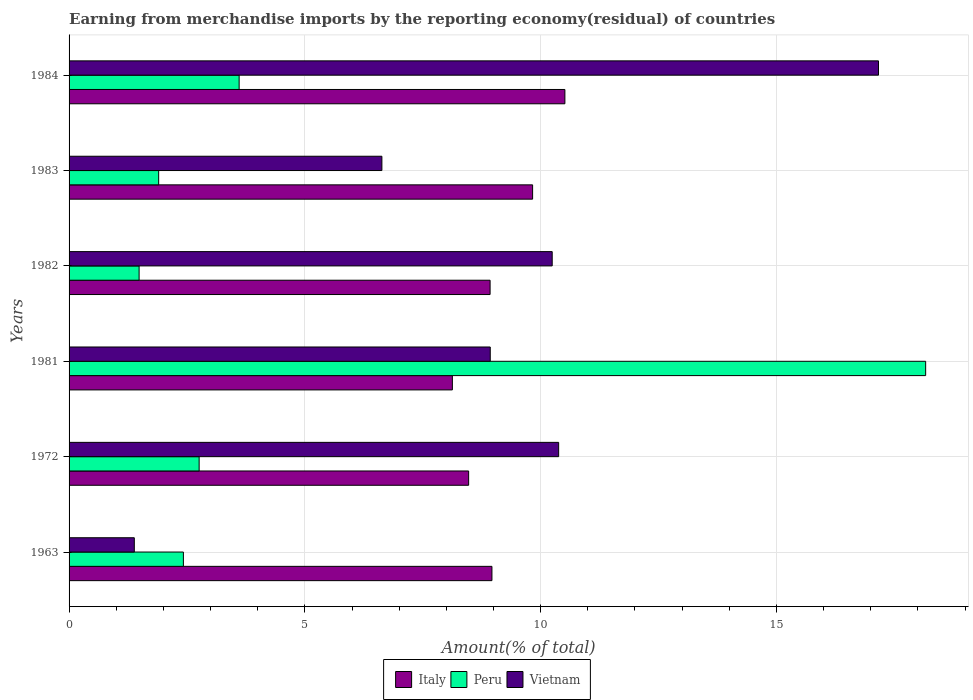How many different coloured bars are there?
Your response must be concise. 3. How many groups of bars are there?
Your answer should be compact. 6. How many bars are there on the 5th tick from the top?
Ensure brevity in your answer.  3. How many bars are there on the 1st tick from the bottom?
Provide a succinct answer. 3. In how many cases, is the number of bars for a given year not equal to the number of legend labels?
Offer a very short reply. 0. What is the percentage of amount earned from merchandise imports in Peru in 1972?
Your answer should be compact. 2.76. Across all years, what is the maximum percentage of amount earned from merchandise imports in Italy?
Ensure brevity in your answer.  10.51. Across all years, what is the minimum percentage of amount earned from merchandise imports in Italy?
Your response must be concise. 8.13. What is the total percentage of amount earned from merchandise imports in Italy in the graph?
Provide a succinct answer. 54.84. What is the difference between the percentage of amount earned from merchandise imports in Italy in 1982 and that in 1983?
Ensure brevity in your answer.  -0.9. What is the difference between the percentage of amount earned from merchandise imports in Peru in 1983 and the percentage of amount earned from merchandise imports in Vietnam in 1963?
Offer a terse response. 0.52. What is the average percentage of amount earned from merchandise imports in Vietnam per year?
Make the answer very short. 9.12. In the year 1984, what is the difference between the percentage of amount earned from merchandise imports in Italy and percentage of amount earned from merchandise imports in Peru?
Provide a succinct answer. 6.91. What is the ratio of the percentage of amount earned from merchandise imports in Peru in 1981 to that in 1983?
Offer a very short reply. 9.56. Is the percentage of amount earned from merchandise imports in Italy in 1981 less than that in 1983?
Give a very brief answer. Yes. What is the difference between the highest and the second highest percentage of amount earned from merchandise imports in Vietnam?
Make the answer very short. 6.78. What is the difference between the highest and the lowest percentage of amount earned from merchandise imports in Peru?
Offer a very short reply. 16.68. In how many years, is the percentage of amount earned from merchandise imports in Italy greater than the average percentage of amount earned from merchandise imports in Italy taken over all years?
Your answer should be very brief. 2. What does the 1st bar from the top in 1983 represents?
Provide a succinct answer. Vietnam. What does the 2nd bar from the bottom in 1981 represents?
Ensure brevity in your answer.  Peru. Is it the case that in every year, the sum of the percentage of amount earned from merchandise imports in Peru and percentage of amount earned from merchandise imports in Vietnam is greater than the percentage of amount earned from merchandise imports in Italy?
Keep it short and to the point. No. Are all the bars in the graph horizontal?
Your answer should be very brief. Yes. How many years are there in the graph?
Provide a succinct answer. 6. What is the difference between two consecutive major ticks on the X-axis?
Your answer should be very brief. 5. Does the graph contain any zero values?
Provide a succinct answer. No. What is the title of the graph?
Provide a succinct answer. Earning from merchandise imports by the reporting economy(residual) of countries. What is the label or title of the X-axis?
Provide a short and direct response. Amount(% of total). What is the Amount(% of total) in Italy in 1963?
Make the answer very short. 8.97. What is the Amount(% of total) of Peru in 1963?
Make the answer very short. 2.42. What is the Amount(% of total) in Vietnam in 1963?
Your response must be concise. 1.38. What is the Amount(% of total) in Italy in 1972?
Keep it short and to the point. 8.47. What is the Amount(% of total) in Peru in 1972?
Make the answer very short. 2.76. What is the Amount(% of total) of Vietnam in 1972?
Make the answer very short. 10.38. What is the Amount(% of total) in Italy in 1981?
Your answer should be very brief. 8.13. What is the Amount(% of total) of Peru in 1981?
Provide a succinct answer. 18.16. What is the Amount(% of total) of Vietnam in 1981?
Provide a short and direct response. 8.93. What is the Amount(% of total) in Italy in 1982?
Your response must be concise. 8.93. What is the Amount(% of total) in Peru in 1982?
Make the answer very short. 1.49. What is the Amount(% of total) in Vietnam in 1982?
Give a very brief answer. 10.24. What is the Amount(% of total) of Italy in 1983?
Provide a short and direct response. 9.83. What is the Amount(% of total) of Peru in 1983?
Give a very brief answer. 1.9. What is the Amount(% of total) in Vietnam in 1983?
Keep it short and to the point. 6.63. What is the Amount(% of total) of Italy in 1984?
Your answer should be very brief. 10.51. What is the Amount(% of total) of Peru in 1984?
Give a very brief answer. 3.61. What is the Amount(% of total) in Vietnam in 1984?
Provide a short and direct response. 17.16. Across all years, what is the maximum Amount(% of total) in Italy?
Ensure brevity in your answer.  10.51. Across all years, what is the maximum Amount(% of total) of Peru?
Ensure brevity in your answer.  18.16. Across all years, what is the maximum Amount(% of total) in Vietnam?
Ensure brevity in your answer.  17.16. Across all years, what is the minimum Amount(% of total) of Italy?
Ensure brevity in your answer.  8.13. Across all years, what is the minimum Amount(% of total) of Peru?
Offer a very short reply. 1.49. Across all years, what is the minimum Amount(% of total) of Vietnam?
Provide a short and direct response. 1.38. What is the total Amount(% of total) in Italy in the graph?
Make the answer very short. 54.84. What is the total Amount(% of total) of Peru in the graph?
Make the answer very short. 30.34. What is the total Amount(% of total) in Vietnam in the graph?
Keep it short and to the point. 54.74. What is the difference between the Amount(% of total) of Italy in 1963 and that in 1972?
Your answer should be compact. 0.49. What is the difference between the Amount(% of total) of Peru in 1963 and that in 1972?
Provide a short and direct response. -0.33. What is the difference between the Amount(% of total) of Vietnam in 1963 and that in 1972?
Offer a very short reply. -9. What is the difference between the Amount(% of total) of Italy in 1963 and that in 1981?
Your response must be concise. 0.84. What is the difference between the Amount(% of total) of Peru in 1963 and that in 1981?
Your answer should be very brief. -15.74. What is the difference between the Amount(% of total) of Vietnam in 1963 and that in 1981?
Your answer should be very brief. -7.55. What is the difference between the Amount(% of total) of Italy in 1963 and that in 1982?
Give a very brief answer. 0.04. What is the difference between the Amount(% of total) of Peru in 1963 and that in 1982?
Your answer should be very brief. 0.94. What is the difference between the Amount(% of total) of Vietnam in 1963 and that in 1982?
Keep it short and to the point. -8.86. What is the difference between the Amount(% of total) of Italy in 1963 and that in 1983?
Your response must be concise. -0.86. What is the difference between the Amount(% of total) in Peru in 1963 and that in 1983?
Provide a succinct answer. 0.52. What is the difference between the Amount(% of total) of Vietnam in 1963 and that in 1983?
Offer a very short reply. -5.25. What is the difference between the Amount(% of total) of Italy in 1963 and that in 1984?
Your answer should be very brief. -1.55. What is the difference between the Amount(% of total) of Peru in 1963 and that in 1984?
Keep it short and to the point. -1.18. What is the difference between the Amount(% of total) of Vietnam in 1963 and that in 1984?
Provide a short and direct response. -15.78. What is the difference between the Amount(% of total) in Italy in 1972 and that in 1981?
Your response must be concise. 0.34. What is the difference between the Amount(% of total) of Peru in 1972 and that in 1981?
Give a very brief answer. -15.41. What is the difference between the Amount(% of total) of Vietnam in 1972 and that in 1981?
Your response must be concise. 1.45. What is the difference between the Amount(% of total) of Italy in 1972 and that in 1982?
Give a very brief answer. -0.46. What is the difference between the Amount(% of total) in Peru in 1972 and that in 1982?
Ensure brevity in your answer.  1.27. What is the difference between the Amount(% of total) in Vietnam in 1972 and that in 1982?
Your answer should be very brief. 0.14. What is the difference between the Amount(% of total) in Italy in 1972 and that in 1983?
Your answer should be compact. -1.36. What is the difference between the Amount(% of total) of Peru in 1972 and that in 1983?
Make the answer very short. 0.86. What is the difference between the Amount(% of total) in Vietnam in 1972 and that in 1983?
Provide a succinct answer. 3.75. What is the difference between the Amount(% of total) in Italy in 1972 and that in 1984?
Make the answer very short. -2.04. What is the difference between the Amount(% of total) of Peru in 1972 and that in 1984?
Provide a short and direct response. -0.85. What is the difference between the Amount(% of total) of Vietnam in 1972 and that in 1984?
Keep it short and to the point. -6.78. What is the difference between the Amount(% of total) in Italy in 1981 and that in 1982?
Make the answer very short. -0.8. What is the difference between the Amount(% of total) in Peru in 1981 and that in 1982?
Make the answer very short. 16.68. What is the difference between the Amount(% of total) in Vietnam in 1981 and that in 1982?
Keep it short and to the point. -1.31. What is the difference between the Amount(% of total) of Italy in 1981 and that in 1983?
Ensure brevity in your answer.  -1.7. What is the difference between the Amount(% of total) in Peru in 1981 and that in 1983?
Keep it short and to the point. 16.26. What is the difference between the Amount(% of total) in Vietnam in 1981 and that in 1983?
Your answer should be compact. 2.3. What is the difference between the Amount(% of total) of Italy in 1981 and that in 1984?
Provide a short and direct response. -2.39. What is the difference between the Amount(% of total) of Peru in 1981 and that in 1984?
Keep it short and to the point. 14.56. What is the difference between the Amount(% of total) in Vietnam in 1981 and that in 1984?
Your answer should be compact. -8.23. What is the difference between the Amount(% of total) in Italy in 1982 and that in 1983?
Keep it short and to the point. -0.9. What is the difference between the Amount(% of total) in Peru in 1982 and that in 1983?
Offer a very short reply. -0.41. What is the difference between the Amount(% of total) in Vietnam in 1982 and that in 1983?
Provide a short and direct response. 3.61. What is the difference between the Amount(% of total) of Italy in 1982 and that in 1984?
Provide a succinct answer. -1.59. What is the difference between the Amount(% of total) of Peru in 1982 and that in 1984?
Make the answer very short. -2.12. What is the difference between the Amount(% of total) in Vietnam in 1982 and that in 1984?
Make the answer very short. -6.92. What is the difference between the Amount(% of total) in Italy in 1983 and that in 1984?
Your response must be concise. -0.68. What is the difference between the Amount(% of total) of Peru in 1983 and that in 1984?
Offer a terse response. -1.71. What is the difference between the Amount(% of total) of Vietnam in 1983 and that in 1984?
Provide a short and direct response. -10.53. What is the difference between the Amount(% of total) in Italy in 1963 and the Amount(% of total) in Peru in 1972?
Provide a succinct answer. 6.21. What is the difference between the Amount(% of total) of Italy in 1963 and the Amount(% of total) of Vietnam in 1972?
Provide a short and direct response. -1.41. What is the difference between the Amount(% of total) of Peru in 1963 and the Amount(% of total) of Vietnam in 1972?
Your answer should be compact. -7.96. What is the difference between the Amount(% of total) of Italy in 1963 and the Amount(% of total) of Peru in 1981?
Make the answer very short. -9.2. What is the difference between the Amount(% of total) in Italy in 1963 and the Amount(% of total) in Vietnam in 1981?
Give a very brief answer. 0.04. What is the difference between the Amount(% of total) of Peru in 1963 and the Amount(% of total) of Vietnam in 1981?
Keep it short and to the point. -6.51. What is the difference between the Amount(% of total) in Italy in 1963 and the Amount(% of total) in Peru in 1982?
Provide a succinct answer. 7.48. What is the difference between the Amount(% of total) of Italy in 1963 and the Amount(% of total) of Vietnam in 1982?
Offer a terse response. -1.28. What is the difference between the Amount(% of total) of Peru in 1963 and the Amount(% of total) of Vietnam in 1982?
Provide a succinct answer. -7.82. What is the difference between the Amount(% of total) of Italy in 1963 and the Amount(% of total) of Peru in 1983?
Your answer should be compact. 7.07. What is the difference between the Amount(% of total) of Italy in 1963 and the Amount(% of total) of Vietnam in 1983?
Offer a very short reply. 2.33. What is the difference between the Amount(% of total) in Peru in 1963 and the Amount(% of total) in Vietnam in 1983?
Your response must be concise. -4.21. What is the difference between the Amount(% of total) in Italy in 1963 and the Amount(% of total) in Peru in 1984?
Make the answer very short. 5.36. What is the difference between the Amount(% of total) in Italy in 1963 and the Amount(% of total) in Vietnam in 1984?
Give a very brief answer. -8.2. What is the difference between the Amount(% of total) of Peru in 1963 and the Amount(% of total) of Vietnam in 1984?
Ensure brevity in your answer.  -14.74. What is the difference between the Amount(% of total) of Italy in 1972 and the Amount(% of total) of Peru in 1981?
Give a very brief answer. -9.69. What is the difference between the Amount(% of total) in Italy in 1972 and the Amount(% of total) in Vietnam in 1981?
Give a very brief answer. -0.46. What is the difference between the Amount(% of total) of Peru in 1972 and the Amount(% of total) of Vietnam in 1981?
Give a very brief answer. -6.17. What is the difference between the Amount(% of total) in Italy in 1972 and the Amount(% of total) in Peru in 1982?
Provide a succinct answer. 6.99. What is the difference between the Amount(% of total) of Italy in 1972 and the Amount(% of total) of Vietnam in 1982?
Make the answer very short. -1.77. What is the difference between the Amount(% of total) of Peru in 1972 and the Amount(% of total) of Vietnam in 1982?
Your answer should be compact. -7.49. What is the difference between the Amount(% of total) in Italy in 1972 and the Amount(% of total) in Peru in 1983?
Offer a very short reply. 6.57. What is the difference between the Amount(% of total) in Italy in 1972 and the Amount(% of total) in Vietnam in 1983?
Provide a succinct answer. 1.84. What is the difference between the Amount(% of total) in Peru in 1972 and the Amount(% of total) in Vietnam in 1983?
Keep it short and to the point. -3.87. What is the difference between the Amount(% of total) in Italy in 1972 and the Amount(% of total) in Peru in 1984?
Keep it short and to the point. 4.87. What is the difference between the Amount(% of total) in Italy in 1972 and the Amount(% of total) in Vietnam in 1984?
Your answer should be compact. -8.69. What is the difference between the Amount(% of total) in Peru in 1972 and the Amount(% of total) in Vietnam in 1984?
Give a very brief answer. -14.41. What is the difference between the Amount(% of total) in Italy in 1981 and the Amount(% of total) in Peru in 1982?
Your answer should be compact. 6.64. What is the difference between the Amount(% of total) in Italy in 1981 and the Amount(% of total) in Vietnam in 1982?
Offer a very short reply. -2.12. What is the difference between the Amount(% of total) of Peru in 1981 and the Amount(% of total) of Vietnam in 1982?
Your answer should be very brief. 7.92. What is the difference between the Amount(% of total) in Italy in 1981 and the Amount(% of total) in Peru in 1983?
Your response must be concise. 6.23. What is the difference between the Amount(% of total) in Italy in 1981 and the Amount(% of total) in Vietnam in 1983?
Your response must be concise. 1.49. What is the difference between the Amount(% of total) in Peru in 1981 and the Amount(% of total) in Vietnam in 1983?
Give a very brief answer. 11.53. What is the difference between the Amount(% of total) in Italy in 1981 and the Amount(% of total) in Peru in 1984?
Offer a terse response. 4.52. What is the difference between the Amount(% of total) of Italy in 1981 and the Amount(% of total) of Vietnam in 1984?
Offer a terse response. -9.04. What is the difference between the Amount(% of total) in Peru in 1981 and the Amount(% of total) in Vietnam in 1984?
Keep it short and to the point. 1. What is the difference between the Amount(% of total) of Italy in 1982 and the Amount(% of total) of Peru in 1983?
Keep it short and to the point. 7.03. What is the difference between the Amount(% of total) of Italy in 1982 and the Amount(% of total) of Vietnam in 1983?
Keep it short and to the point. 2.29. What is the difference between the Amount(% of total) in Peru in 1982 and the Amount(% of total) in Vietnam in 1983?
Ensure brevity in your answer.  -5.15. What is the difference between the Amount(% of total) in Italy in 1982 and the Amount(% of total) in Peru in 1984?
Provide a succinct answer. 5.32. What is the difference between the Amount(% of total) of Italy in 1982 and the Amount(% of total) of Vietnam in 1984?
Provide a succinct answer. -8.24. What is the difference between the Amount(% of total) of Peru in 1982 and the Amount(% of total) of Vietnam in 1984?
Provide a short and direct response. -15.68. What is the difference between the Amount(% of total) of Italy in 1983 and the Amount(% of total) of Peru in 1984?
Provide a short and direct response. 6.22. What is the difference between the Amount(% of total) in Italy in 1983 and the Amount(% of total) in Vietnam in 1984?
Keep it short and to the point. -7.33. What is the difference between the Amount(% of total) of Peru in 1983 and the Amount(% of total) of Vietnam in 1984?
Offer a very short reply. -15.26. What is the average Amount(% of total) in Italy per year?
Your answer should be very brief. 9.14. What is the average Amount(% of total) of Peru per year?
Offer a terse response. 5.06. What is the average Amount(% of total) of Vietnam per year?
Provide a succinct answer. 9.12. In the year 1963, what is the difference between the Amount(% of total) of Italy and Amount(% of total) of Peru?
Your answer should be compact. 6.54. In the year 1963, what is the difference between the Amount(% of total) in Italy and Amount(% of total) in Vietnam?
Provide a short and direct response. 7.58. In the year 1963, what is the difference between the Amount(% of total) of Peru and Amount(% of total) of Vietnam?
Keep it short and to the point. 1.04. In the year 1972, what is the difference between the Amount(% of total) in Italy and Amount(% of total) in Peru?
Provide a succinct answer. 5.71. In the year 1972, what is the difference between the Amount(% of total) in Italy and Amount(% of total) in Vietnam?
Ensure brevity in your answer.  -1.91. In the year 1972, what is the difference between the Amount(% of total) of Peru and Amount(% of total) of Vietnam?
Your answer should be very brief. -7.62. In the year 1981, what is the difference between the Amount(% of total) of Italy and Amount(% of total) of Peru?
Your answer should be very brief. -10.04. In the year 1981, what is the difference between the Amount(% of total) in Italy and Amount(% of total) in Vietnam?
Provide a succinct answer. -0.8. In the year 1981, what is the difference between the Amount(% of total) of Peru and Amount(% of total) of Vietnam?
Offer a very short reply. 9.23. In the year 1982, what is the difference between the Amount(% of total) of Italy and Amount(% of total) of Peru?
Offer a terse response. 7.44. In the year 1982, what is the difference between the Amount(% of total) of Italy and Amount(% of total) of Vietnam?
Keep it short and to the point. -1.32. In the year 1982, what is the difference between the Amount(% of total) in Peru and Amount(% of total) in Vietnam?
Ensure brevity in your answer.  -8.76. In the year 1983, what is the difference between the Amount(% of total) in Italy and Amount(% of total) in Peru?
Make the answer very short. 7.93. In the year 1983, what is the difference between the Amount(% of total) in Italy and Amount(% of total) in Vietnam?
Provide a short and direct response. 3.2. In the year 1983, what is the difference between the Amount(% of total) of Peru and Amount(% of total) of Vietnam?
Offer a terse response. -4.73. In the year 1984, what is the difference between the Amount(% of total) of Italy and Amount(% of total) of Peru?
Your response must be concise. 6.91. In the year 1984, what is the difference between the Amount(% of total) of Italy and Amount(% of total) of Vietnam?
Offer a terse response. -6.65. In the year 1984, what is the difference between the Amount(% of total) of Peru and Amount(% of total) of Vietnam?
Give a very brief answer. -13.56. What is the ratio of the Amount(% of total) in Italy in 1963 to that in 1972?
Your answer should be very brief. 1.06. What is the ratio of the Amount(% of total) of Peru in 1963 to that in 1972?
Your answer should be very brief. 0.88. What is the ratio of the Amount(% of total) in Vietnam in 1963 to that in 1972?
Keep it short and to the point. 0.13. What is the ratio of the Amount(% of total) in Italy in 1963 to that in 1981?
Your answer should be compact. 1.1. What is the ratio of the Amount(% of total) of Peru in 1963 to that in 1981?
Give a very brief answer. 0.13. What is the ratio of the Amount(% of total) of Vietnam in 1963 to that in 1981?
Offer a very short reply. 0.15. What is the ratio of the Amount(% of total) in Peru in 1963 to that in 1982?
Provide a short and direct response. 1.63. What is the ratio of the Amount(% of total) of Vietnam in 1963 to that in 1982?
Your answer should be compact. 0.14. What is the ratio of the Amount(% of total) in Italy in 1963 to that in 1983?
Your answer should be compact. 0.91. What is the ratio of the Amount(% of total) in Peru in 1963 to that in 1983?
Make the answer very short. 1.28. What is the ratio of the Amount(% of total) of Vietnam in 1963 to that in 1983?
Your answer should be compact. 0.21. What is the ratio of the Amount(% of total) in Italy in 1963 to that in 1984?
Ensure brevity in your answer.  0.85. What is the ratio of the Amount(% of total) in Peru in 1963 to that in 1984?
Make the answer very short. 0.67. What is the ratio of the Amount(% of total) of Vietnam in 1963 to that in 1984?
Make the answer very short. 0.08. What is the ratio of the Amount(% of total) in Italy in 1972 to that in 1981?
Offer a very short reply. 1.04. What is the ratio of the Amount(% of total) in Peru in 1972 to that in 1981?
Your answer should be compact. 0.15. What is the ratio of the Amount(% of total) of Vietnam in 1972 to that in 1981?
Ensure brevity in your answer.  1.16. What is the ratio of the Amount(% of total) in Italy in 1972 to that in 1982?
Give a very brief answer. 0.95. What is the ratio of the Amount(% of total) of Peru in 1972 to that in 1982?
Your answer should be compact. 1.86. What is the ratio of the Amount(% of total) in Vietnam in 1972 to that in 1982?
Give a very brief answer. 1.01. What is the ratio of the Amount(% of total) in Italy in 1972 to that in 1983?
Ensure brevity in your answer.  0.86. What is the ratio of the Amount(% of total) in Peru in 1972 to that in 1983?
Give a very brief answer. 1.45. What is the ratio of the Amount(% of total) of Vietnam in 1972 to that in 1983?
Keep it short and to the point. 1.57. What is the ratio of the Amount(% of total) in Italy in 1972 to that in 1984?
Give a very brief answer. 0.81. What is the ratio of the Amount(% of total) of Peru in 1972 to that in 1984?
Your answer should be very brief. 0.76. What is the ratio of the Amount(% of total) of Vietnam in 1972 to that in 1984?
Make the answer very short. 0.6. What is the ratio of the Amount(% of total) in Italy in 1981 to that in 1982?
Offer a terse response. 0.91. What is the ratio of the Amount(% of total) of Peru in 1981 to that in 1982?
Ensure brevity in your answer.  12.23. What is the ratio of the Amount(% of total) of Vietnam in 1981 to that in 1982?
Offer a terse response. 0.87. What is the ratio of the Amount(% of total) in Italy in 1981 to that in 1983?
Make the answer very short. 0.83. What is the ratio of the Amount(% of total) in Peru in 1981 to that in 1983?
Give a very brief answer. 9.56. What is the ratio of the Amount(% of total) of Vietnam in 1981 to that in 1983?
Keep it short and to the point. 1.35. What is the ratio of the Amount(% of total) of Italy in 1981 to that in 1984?
Give a very brief answer. 0.77. What is the ratio of the Amount(% of total) in Peru in 1981 to that in 1984?
Offer a very short reply. 5.04. What is the ratio of the Amount(% of total) in Vietnam in 1981 to that in 1984?
Your response must be concise. 0.52. What is the ratio of the Amount(% of total) in Italy in 1982 to that in 1983?
Keep it short and to the point. 0.91. What is the ratio of the Amount(% of total) of Peru in 1982 to that in 1983?
Make the answer very short. 0.78. What is the ratio of the Amount(% of total) of Vietnam in 1982 to that in 1983?
Keep it short and to the point. 1.54. What is the ratio of the Amount(% of total) in Italy in 1982 to that in 1984?
Ensure brevity in your answer.  0.85. What is the ratio of the Amount(% of total) of Peru in 1982 to that in 1984?
Offer a very short reply. 0.41. What is the ratio of the Amount(% of total) of Vietnam in 1982 to that in 1984?
Your answer should be very brief. 0.6. What is the ratio of the Amount(% of total) in Italy in 1983 to that in 1984?
Offer a terse response. 0.93. What is the ratio of the Amount(% of total) of Peru in 1983 to that in 1984?
Make the answer very short. 0.53. What is the ratio of the Amount(% of total) in Vietnam in 1983 to that in 1984?
Your answer should be very brief. 0.39. What is the difference between the highest and the second highest Amount(% of total) in Italy?
Your response must be concise. 0.68. What is the difference between the highest and the second highest Amount(% of total) in Peru?
Your response must be concise. 14.56. What is the difference between the highest and the second highest Amount(% of total) in Vietnam?
Keep it short and to the point. 6.78. What is the difference between the highest and the lowest Amount(% of total) in Italy?
Your response must be concise. 2.39. What is the difference between the highest and the lowest Amount(% of total) in Peru?
Offer a very short reply. 16.68. What is the difference between the highest and the lowest Amount(% of total) of Vietnam?
Offer a very short reply. 15.78. 